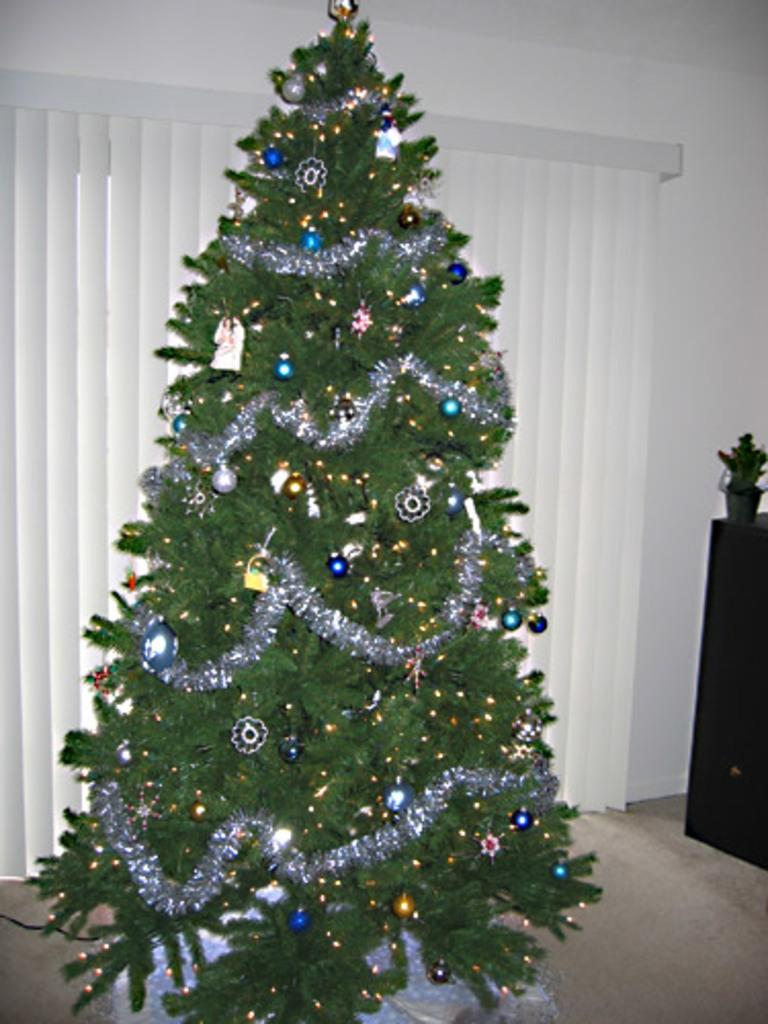What type of object is decorated in the image? There is a tree in the image that is decorated with ribbons, balls, lights, and ornaments. What other objects can be seen in the image? There is a plant in a pot on a table and a window blind in the image. What is the background of the image? There is a wall in the image. What type of pen is used to draw the animal on the wall in the image? There is no animal drawn on the wall in the image, and therefore no pen is used for that purpose. 